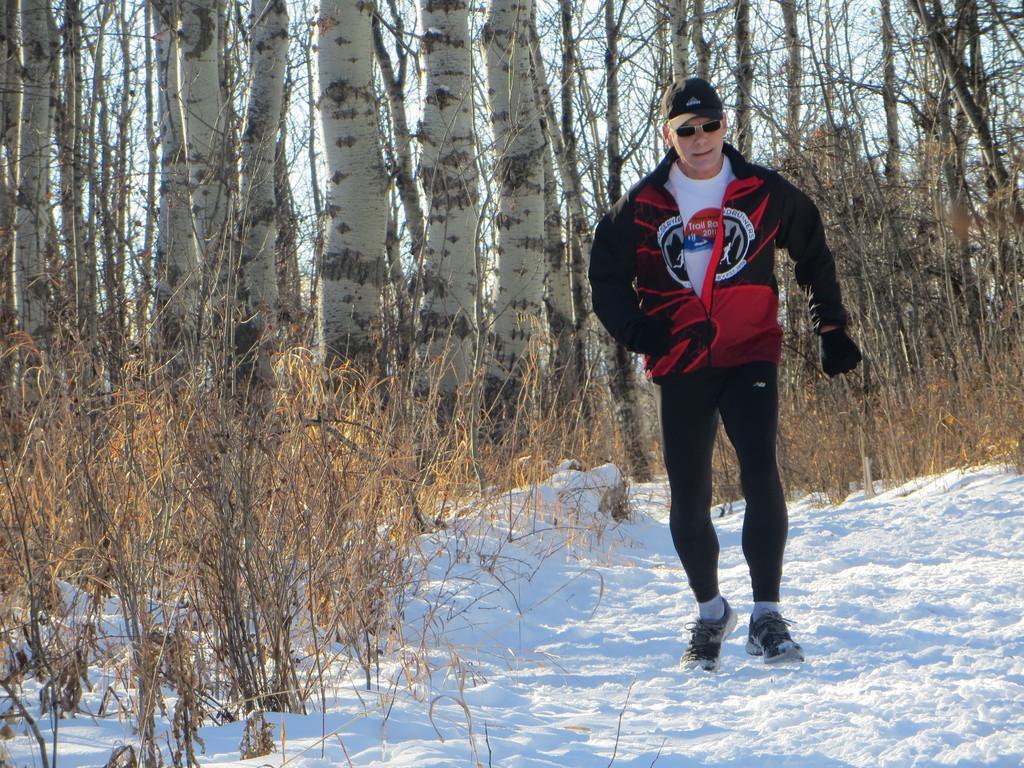Could you give a brief overview of what you see in this image? In this image there is a man wearing sweater, glasses and a cap walking on a snow surface and there are plants, in the background there are trees. 